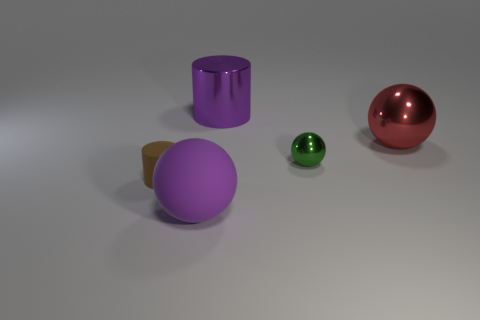Add 4 large purple rubber objects. How many objects exist? 9 Subtract all balls. How many objects are left? 2 Subtract 0 yellow cylinders. How many objects are left? 5 Subtract all purple rubber things. Subtract all tiny metal spheres. How many objects are left? 3 Add 5 large red shiny things. How many large red shiny things are left? 6 Add 2 purple metal spheres. How many purple metal spheres exist? 2 